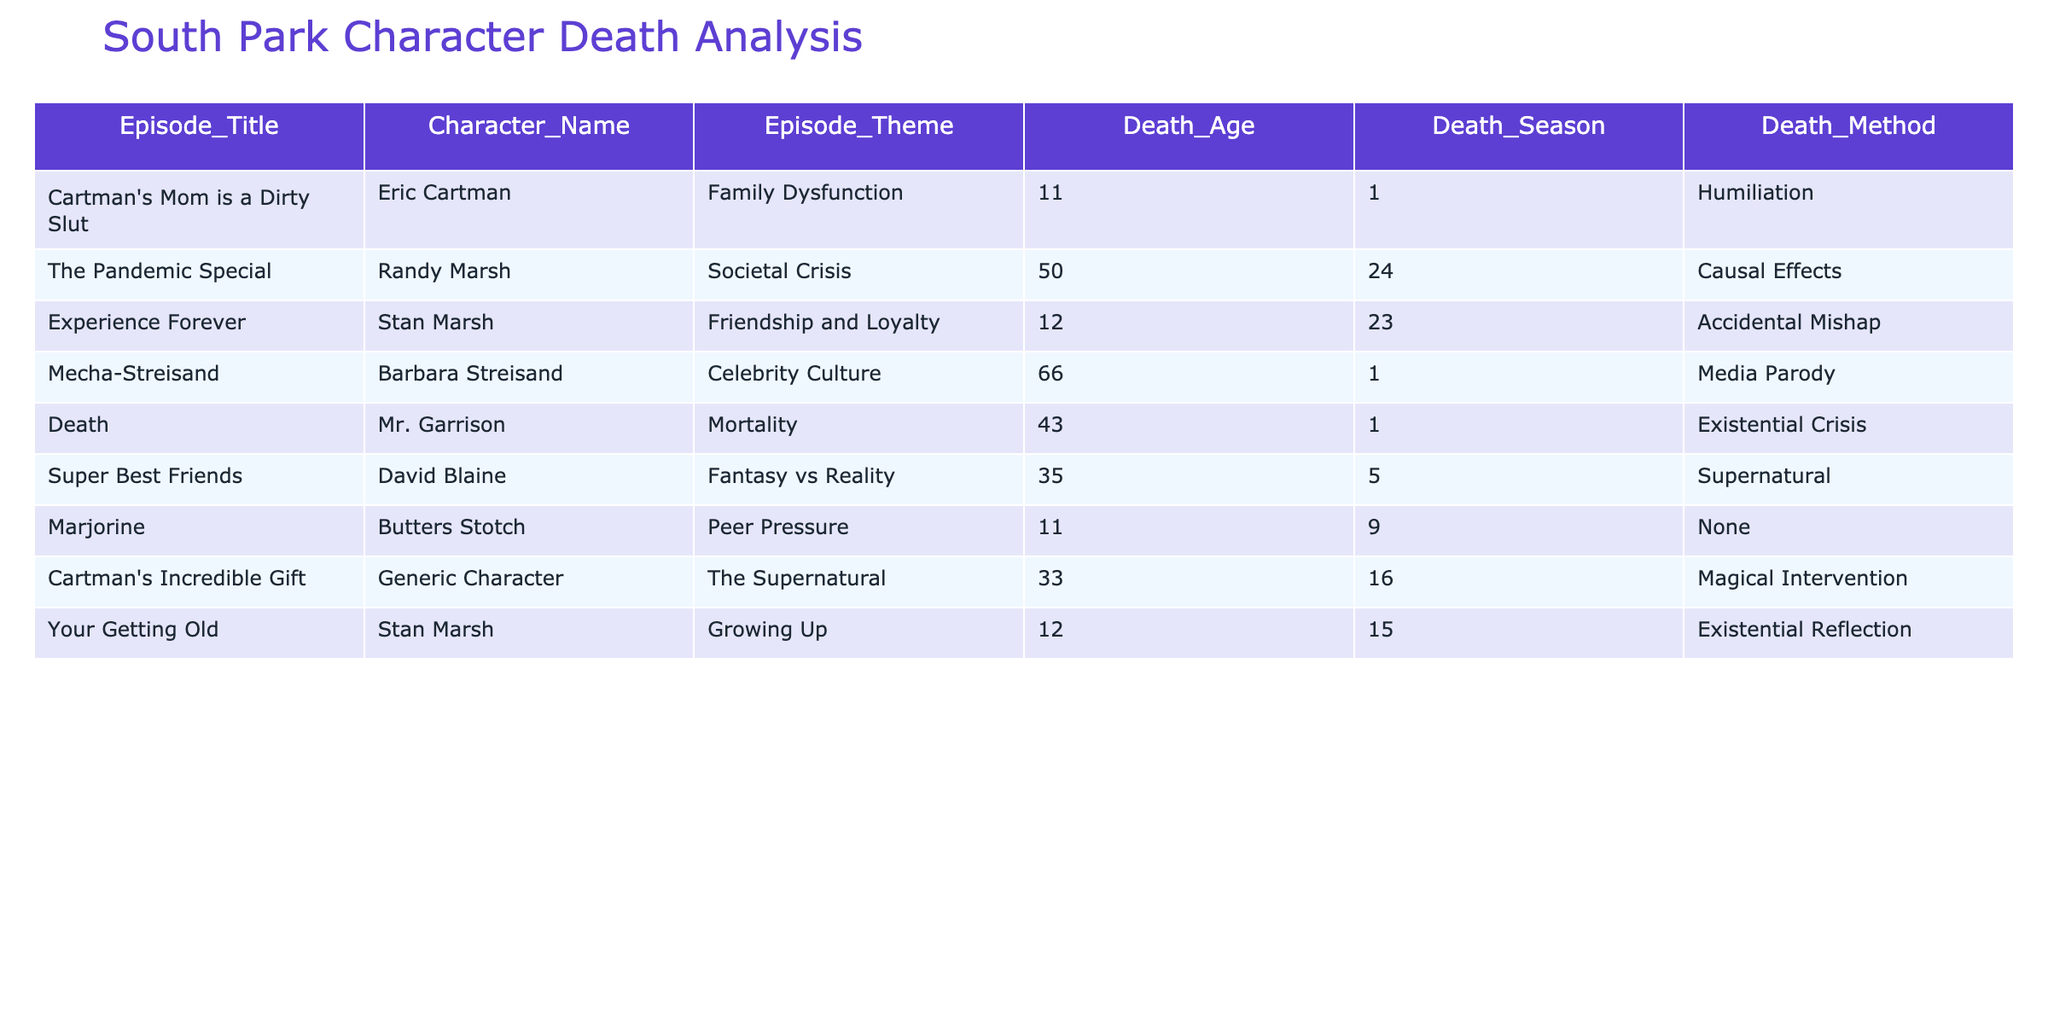What is the death method for Stan Marsh in 'Your Getting Old'? The table shows that the death method for Stan Marsh in the episode 'Your Getting Old' is listed as "Existential Reflection".
Answer: Existential Reflection Who is the youngest character to die in the table? The youngest character in the table is Butters Stotch, who died at the age of 11 in the episode 'Marjorine'.
Answer: Butters Stotch How many characters died as a result of societal crises? From the table, Randy Marsh in 'The Pandemic Special' is the only character who died from a societal crisis, making it a total of 1 character.
Answer: 1 What is the average age at death for characters affected by celebrity culture and mortality themes? The ages at death for those themes are 66 (Barbara Streisand, Celebrity Culture) and 43 (Mr. Garrison, Mortality). The average is calculated as (66 + 43) / 2 = 54.5.
Answer: 54.5 Is there a character who died due to magical intervention? According to the table, there is a character that died due to magical intervention, which is a Generic Character in 'Cartman's Incredible Gift'.
Answer: Yes Which episode theme has the highest age of death? The episode theme with the highest age of death is "Celebrity Culture," where Barbara Streisand died at age 66.
Answer: Celebrity Culture How many characters died in total across all episodes listed? By adding all the characters from the table, the total number of characters is 8, as each row represents a unique death.
Answer: 8 What is the death method for the character who died at age 12? Two characters died at age 12: Stan Marsh in 'Experience Forever' died from 'Accidental Mishap,' and Stan Marsh in 'Your Getting Old' died from 'Existential Reflection.'
Answer: Accidental Mishap; Existential Reflection Which episode features a character that died due to peer pressure? The table indicates that Butters Stotch died due to peer pressure in the episode 'Marjorine.'
Answer: Marjorine 